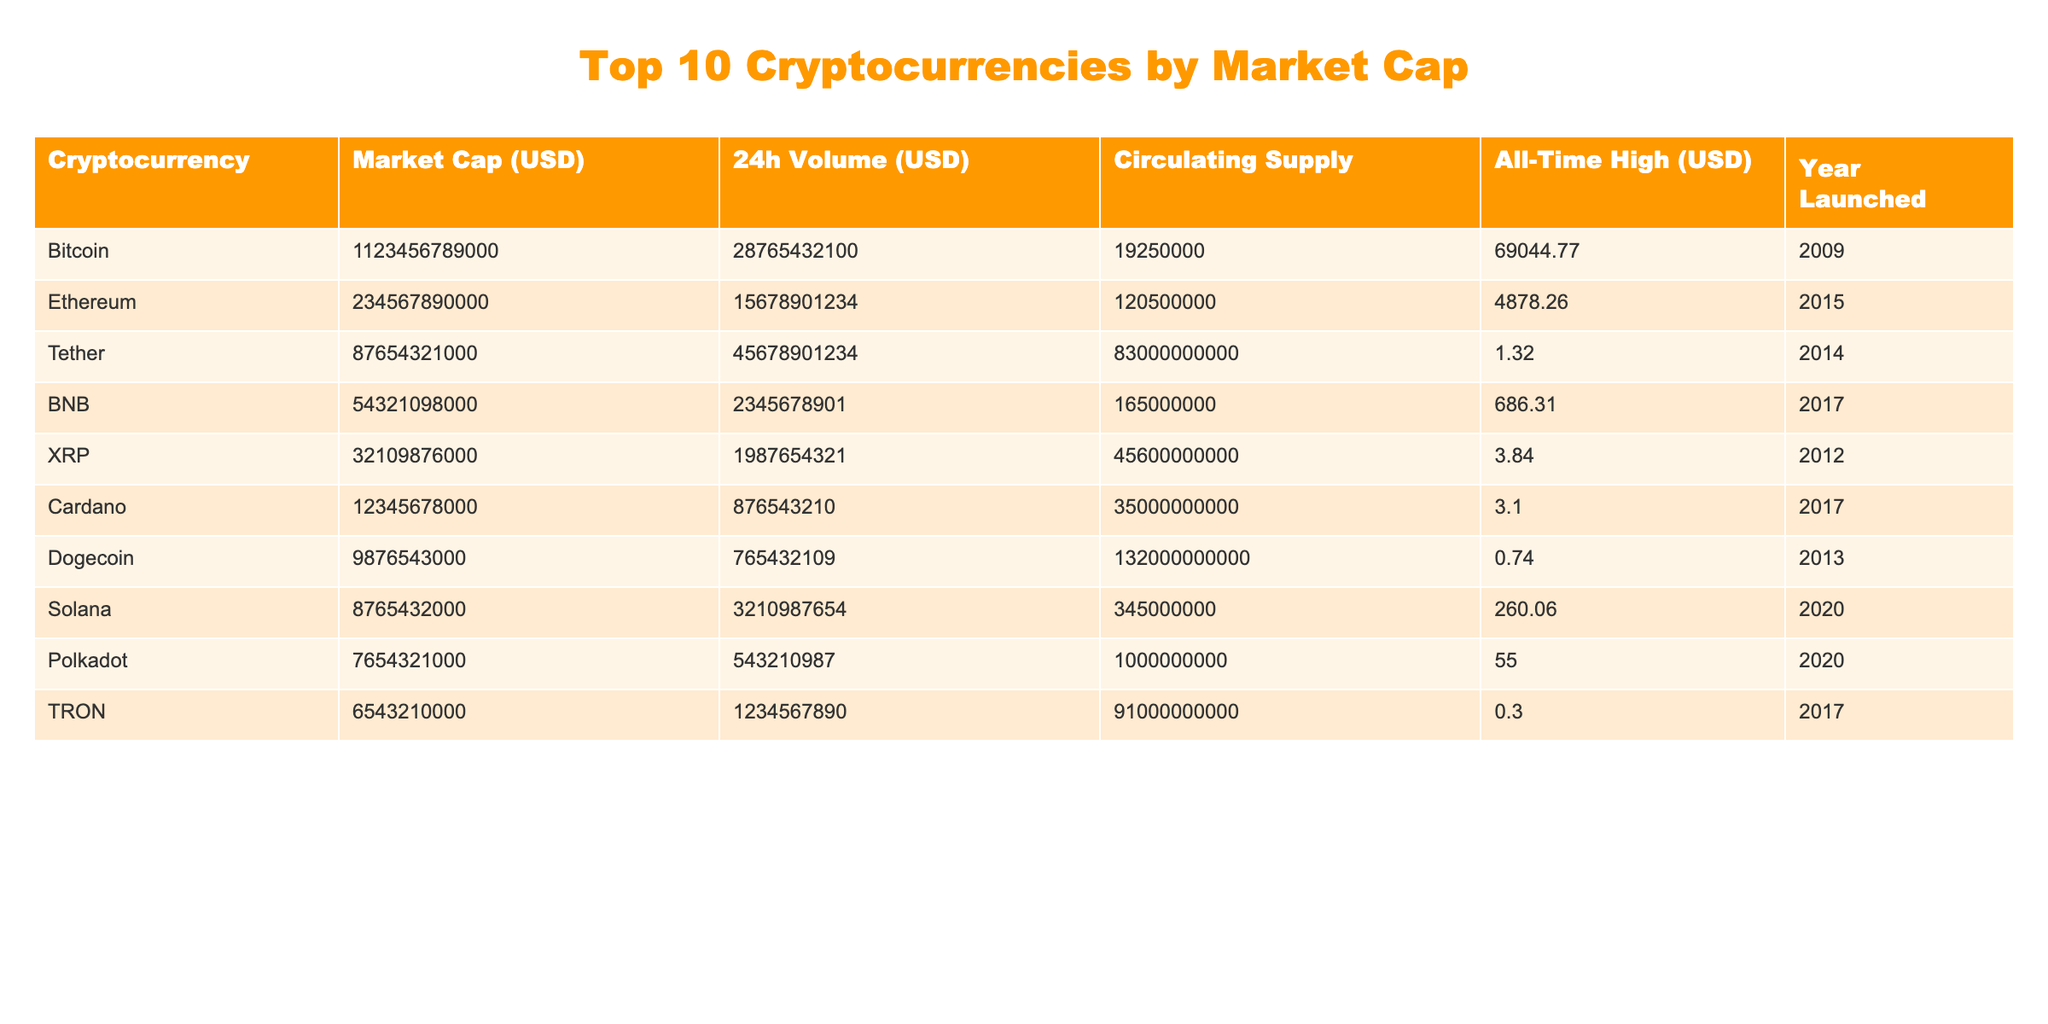What is the market cap of Bitcoin? The table lists Bitcoin with a market cap of 1,123,456,789,000 USD in the second column.
Answer: 1,123,456,789,000 USD Which cryptocurrency has the highest all-time high value? The all-time high values are listed, and Bitcoin has the highest value at 69,044.77 USD.
Answer: Bitcoin What is the average circulating supply of the top 10 cryptocurrencies? To find the average, add the circulating supplies (19,250,000 + 120,500,000 + 83,000,000,000 + 165,000,000 + 45,600,000,000 + 35,000,000,000 + 132,000,000,000 + 345,000,000 + 1,000,000,000 + 91,000,000,000 = 94,834,000,000) and divide by 10, which gives 9,483,400,000.
Answer: 9,483,400,000 Is Cardano's all-time high value greater than 3 USD? The table shows Cardano’s all-time high value as 3.10 USD, which is greater than 3 USD, making the statement true.
Answer: Yes What is the difference between Ethereum's market cap and Tether's market cap? Ethereum has a market cap of 234,567,890,000 USD and Tether has 87,654,321,000 USD. The difference is 87,654,321,000 - 234,567,890,000 = -146,912,579,000 USD, indicating that Ethereum's market cap is lower.
Answer: -146,912,579,000 USD Are there any cryptocurrencies launched in the same year as TRON? TRON was launched in 2017. By checking the table, BNB, Cardano, and TRON all launched in 2017, confirming that there are others.
Answer: Yes What is the total 24h trading volume for Bitcoin and Ethereum combined? For Bitcoin, the volume is 28,765,432,100 USD, and for Ethereum, it is 15,678,901,234 USD. The total volume is 28,765,432,100 + 15,678,901,234 = 44,444,333,334 USD.
Answer: 44,444,333,334 USD Which cryptocurrency has the lowest market cap? By reviewing the market cap values, Dogecoin has the lowest at 9,876,543,000 USD among the listed cryptocurrencies.
Answer: Dogecoin What could be inferred about the market cap trend based on the year launched? The trend suggests that older coins like Bitcoin and Ethereum with higher market caps indicate a longer establishment in the market, while newer launches like Solana, with lower market caps, reflect initial growth stages.
Answer: Market cap tends to be higher for older cryptocurrencies How does the circulating supply of Dogecoin compare to Ethereum? Dogecoin has a circulating supply of 132,000,000,000 while Ethereum has 120,500,000. Comparing the two shows that Dogecoin has a substantially higher supply.
Answer: Dogecoin has a higher circulating supply Which cryptocurrency has a market cap almost equal to its all-time high value? By visually inspecting the values, Tether's market cap (87,654,321,000) compared to its all-time high (1.32) shows a significant difference. Looking closely, no cryptocurrencies have market caps close to their all-time highs, indicating none fit this criterion.
Answer: None 